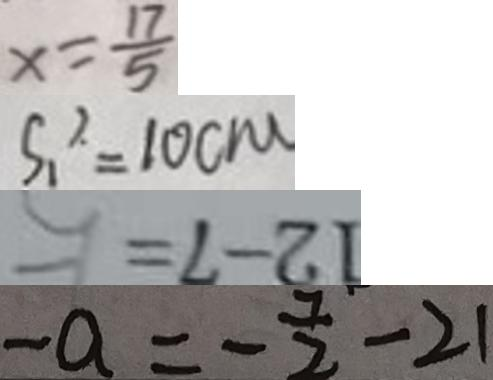Convert formula to latex. <formula><loc_0><loc_0><loc_500><loc_500>x = \frac { 1 7 } { 5 } 
 S _ { 1 } ^ { 2 } = 1 0 c m 
 1 2 - 7 = 
 - a = - \frac { 7 } { 2 } - 2 1</formula> 